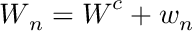<formula> <loc_0><loc_0><loc_500><loc_500>W _ { n } = W ^ { c } + w _ { n }</formula> 